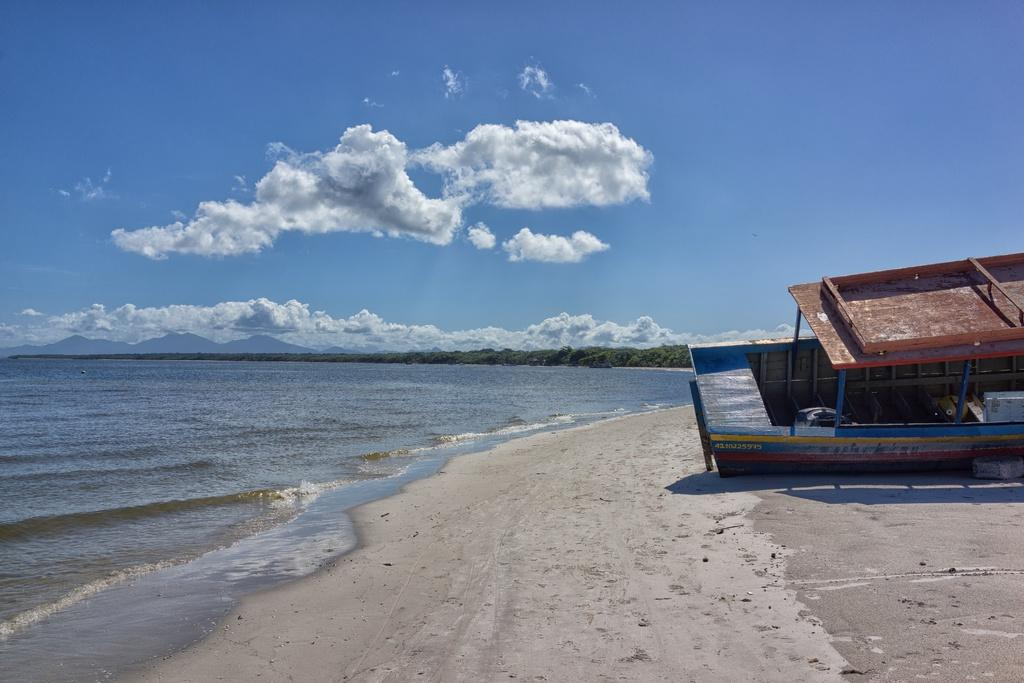What is located on the right side of the image? There is a boat on the right side of the image. Where is the boat situated in relation to the land? The boat is on the land. What can be seen on the left side of the image? There is an ocean on the left side of the image. What is the condition of the sky in the image? The sky is cloudy. What type of vegetation is visible in the background of the image? There are trees in the background of the image. What type of school does the dad attend in the image? There is no dad or school present in the image. 